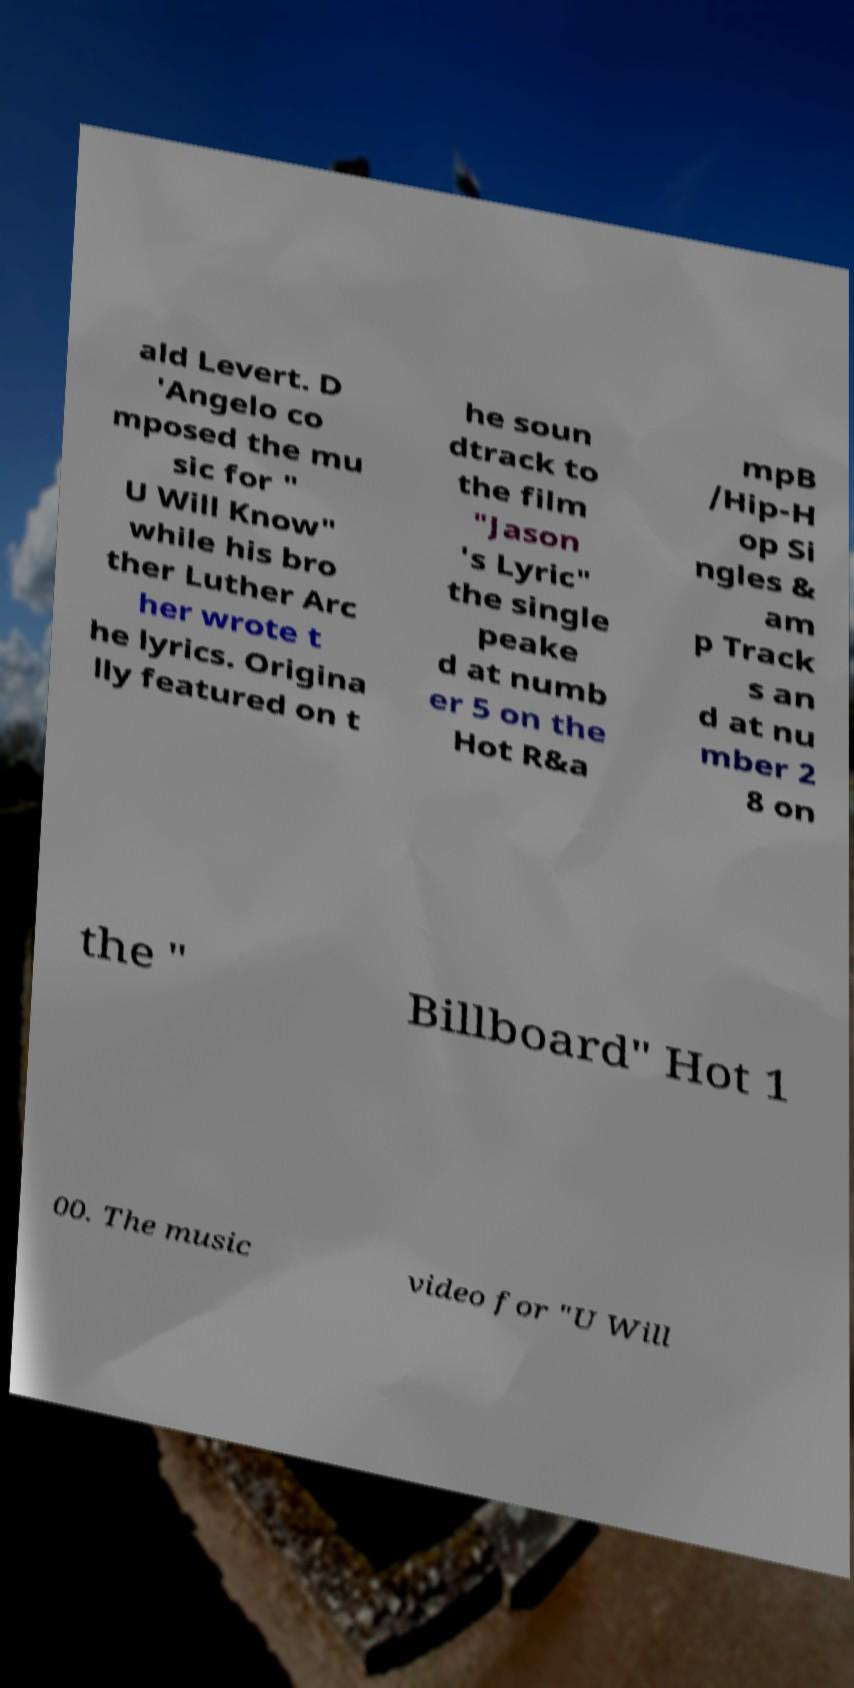What messages or text are displayed in this image? I need them in a readable, typed format. ald Levert. D 'Angelo co mposed the mu sic for " U Will Know" while his bro ther Luther Arc her wrote t he lyrics. Origina lly featured on t he soun dtrack to the film "Jason 's Lyric" the single peake d at numb er 5 on the Hot R&a mpB /Hip-H op Si ngles & am p Track s an d at nu mber 2 8 on the " Billboard" Hot 1 00. The music video for "U Will 